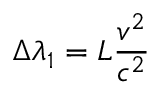Convert formula to latex. <formula><loc_0><loc_0><loc_500><loc_500>\Delta { \lambda } _ { 1 } = { L } { \frac { v ^ { 2 } } { c ^ { 2 } } }</formula> 